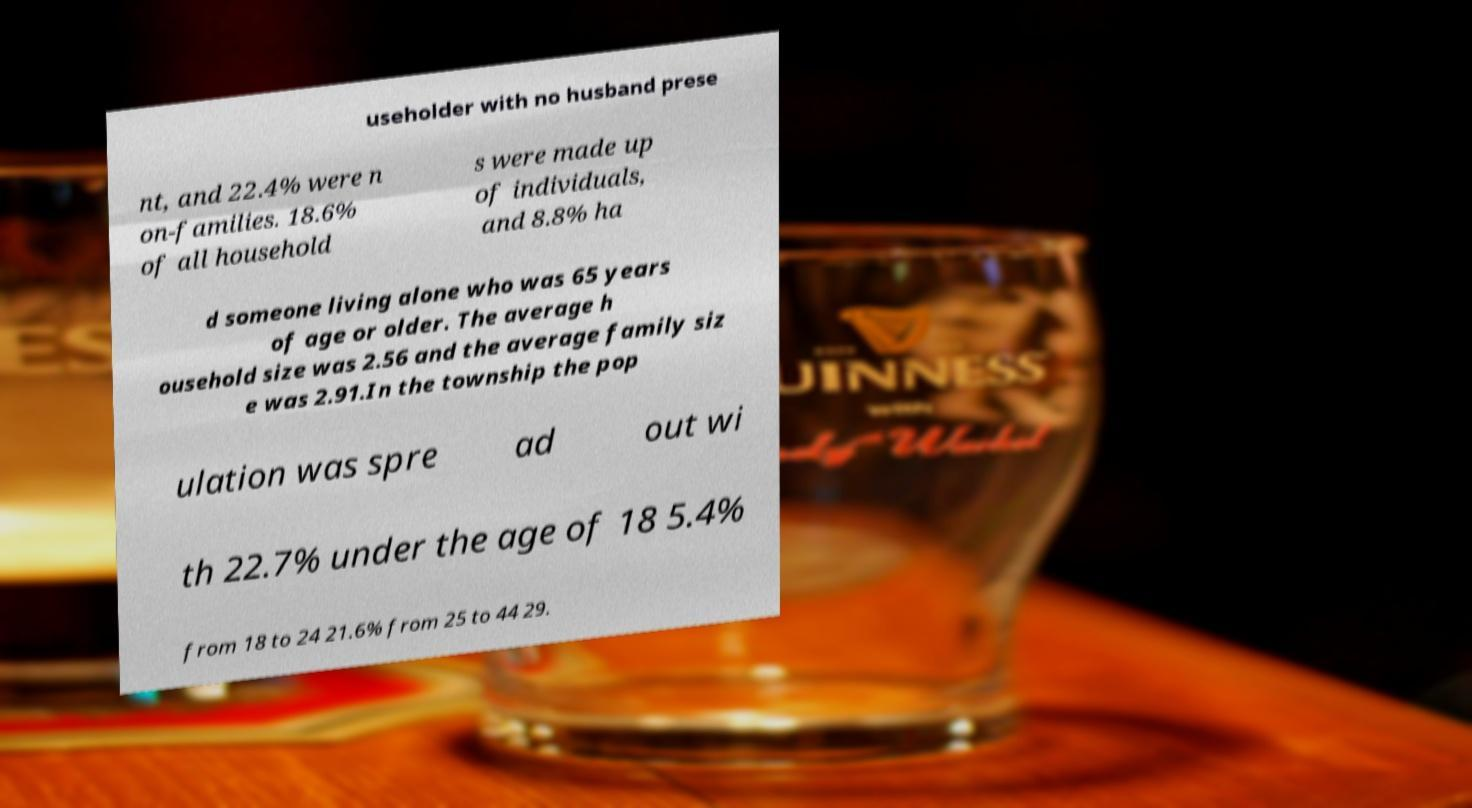What messages or text are displayed in this image? I need them in a readable, typed format. useholder with no husband prese nt, and 22.4% were n on-families. 18.6% of all household s were made up of individuals, and 8.8% ha d someone living alone who was 65 years of age or older. The average h ousehold size was 2.56 and the average family siz e was 2.91.In the township the pop ulation was spre ad out wi th 22.7% under the age of 18 5.4% from 18 to 24 21.6% from 25 to 44 29. 